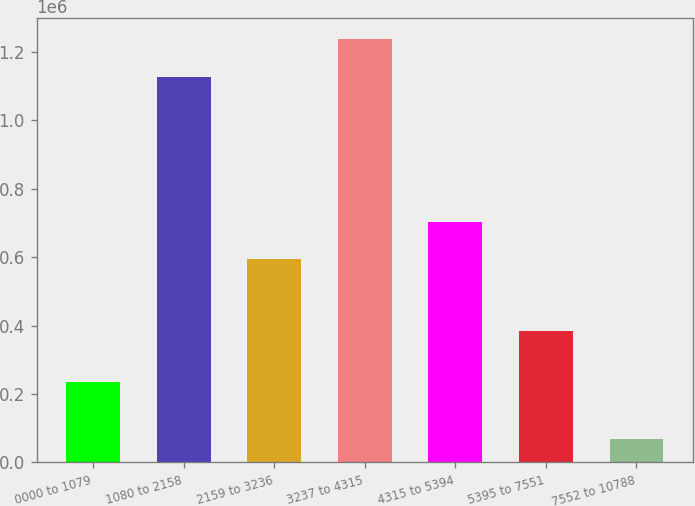Convert chart to OTSL. <chart><loc_0><loc_0><loc_500><loc_500><bar_chart><fcel>0000 to 1079<fcel>1080 to 2158<fcel>2159 to 3236<fcel>3237 to 4315<fcel>4315 to 5394<fcel>5395 to 7551<fcel>7552 to 10788<nl><fcel>234939<fcel>1.12634e+06<fcel>593293<fcel>1.23699e+06<fcel>703945<fcel>382900<fcel>68500<nl></chart> 